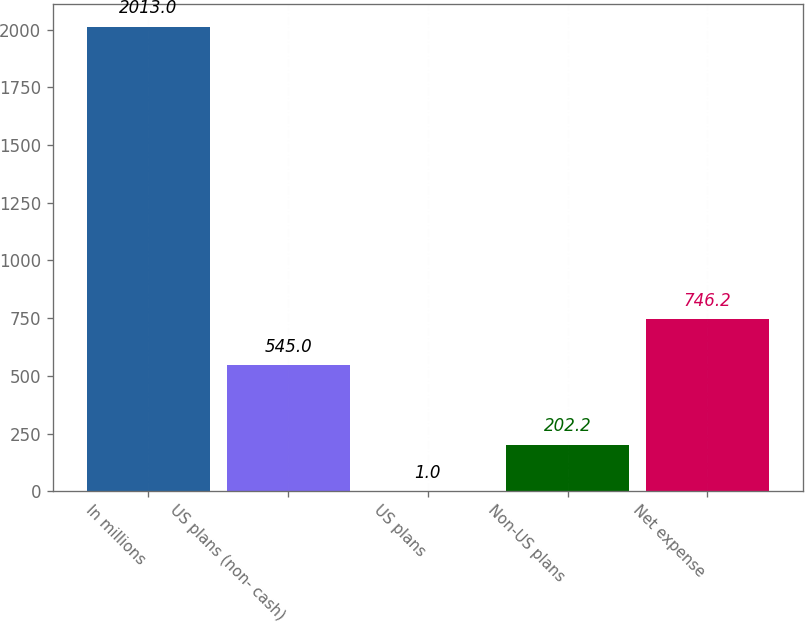<chart> <loc_0><loc_0><loc_500><loc_500><bar_chart><fcel>In millions<fcel>US plans (non- cash)<fcel>US plans<fcel>Non-US plans<fcel>Net expense<nl><fcel>2013<fcel>545<fcel>1<fcel>202.2<fcel>746.2<nl></chart> 